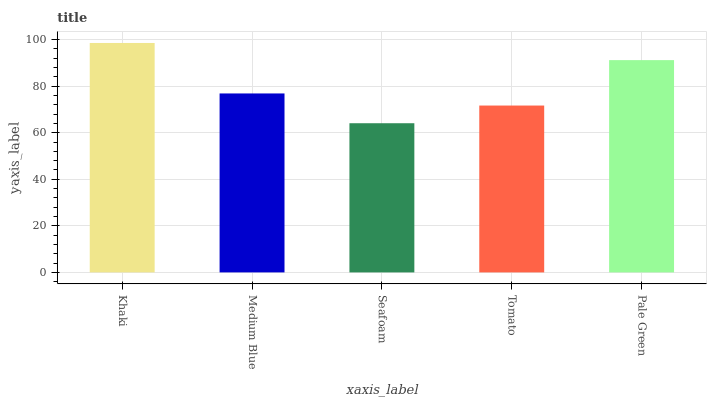Is Seafoam the minimum?
Answer yes or no. Yes. Is Khaki the maximum?
Answer yes or no. Yes. Is Medium Blue the minimum?
Answer yes or no. No. Is Medium Blue the maximum?
Answer yes or no. No. Is Khaki greater than Medium Blue?
Answer yes or no. Yes. Is Medium Blue less than Khaki?
Answer yes or no. Yes. Is Medium Blue greater than Khaki?
Answer yes or no. No. Is Khaki less than Medium Blue?
Answer yes or no. No. Is Medium Blue the high median?
Answer yes or no. Yes. Is Medium Blue the low median?
Answer yes or no. Yes. Is Khaki the high median?
Answer yes or no. No. Is Khaki the low median?
Answer yes or no. No. 